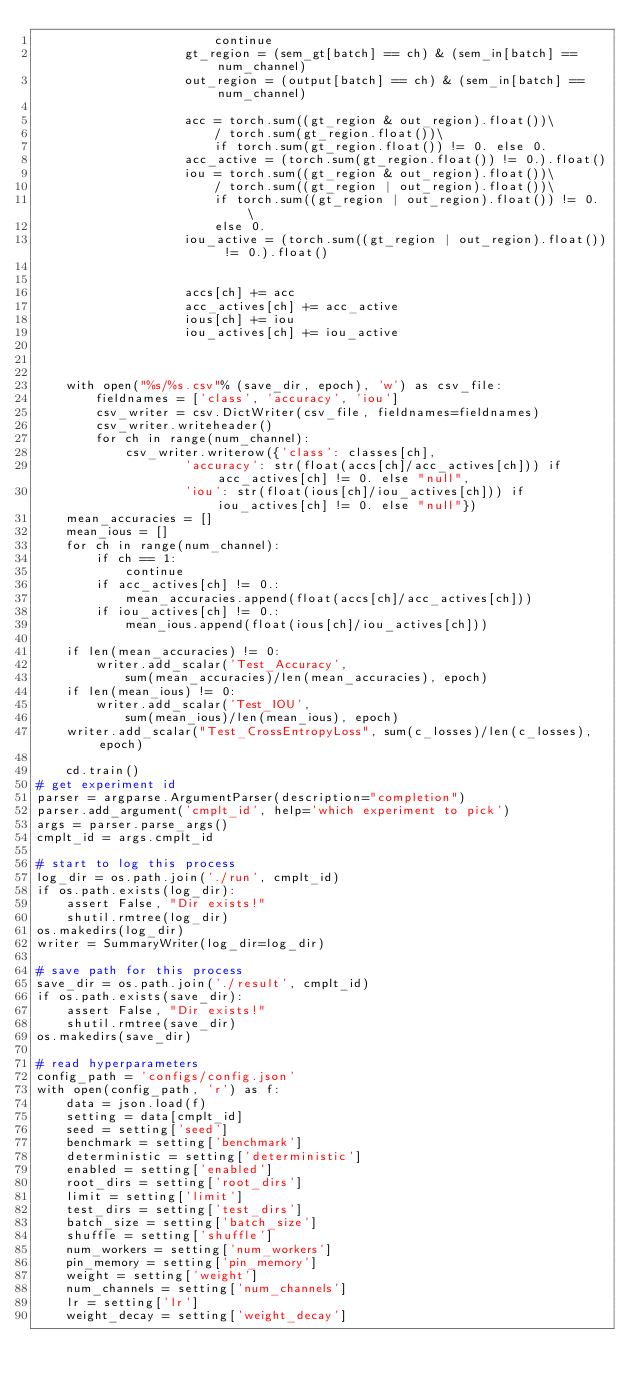Convert code to text. <code><loc_0><loc_0><loc_500><loc_500><_Python_>                        continue
                    gt_region = (sem_gt[batch] == ch) & (sem_in[batch] == num_channel)
                    out_region = (output[batch] == ch) & (sem_in[batch] == num_channel)

                    acc = torch.sum((gt_region & out_region).float())\
                        / torch.sum(gt_region.float())\
                        if torch.sum(gt_region.float()) != 0. else 0.
                    acc_active = (torch.sum(gt_region.float()) != 0.).float()
                    iou = torch.sum((gt_region & out_region).float())\
                        / torch.sum((gt_region | out_region).float())\
                        if torch.sum((gt_region | out_region).float()) != 0. \
                        else 0.
                    iou_active = (torch.sum((gt_region | out_region).float()) != 0.).float()


                    accs[ch] += acc
                    acc_actives[ch] += acc_active
                    ious[ch] += iou
                    iou_actives[ch] += iou_active
            


    with open("%s/%s.csv"% (save_dir, epoch), 'w') as csv_file:
        fieldnames = ['class', 'accuracy', 'iou']
        csv_writer = csv.DictWriter(csv_file, fieldnames=fieldnames)
        csv_writer.writeheader()
        for ch in range(num_channel):
            csv_writer.writerow({'class': classes[ch],
                    'accuracy': str(float(accs[ch]/acc_actives[ch])) if acc_actives[ch] != 0. else "null", 
                    'iou': str(float(ious[ch]/iou_actives[ch])) if iou_actives[ch] != 0. else "null"})
    mean_accuracies = []
    mean_ious = []
    for ch in range(num_channel):
        if ch == 1:
            continue
        if acc_actives[ch] != 0.:
            mean_accuracies.append(float(accs[ch]/acc_actives[ch]))
        if iou_actives[ch] != 0.:
            mean_ious.append(float(ious[ch]/iou_actives[ch]))

    if len(mean_accuracies) != 0:        
        writer.add_scalar('Test_Accuracy',
            sum(mean_accuracies)/len(mean_accuracies), epoch)
    if len(mean_ious) != 0:
        writer.add_scalar('Test_IOU',
            sum(mean_ious)/len(mean_ious), epoch)
    writer.add_scalar("Test_CrossEntropyLoss", sum(c_losses)/len(c_losses), epoch)

    cd.train()
# get experiment id
parser = argparse.ArgumentParser(description="completion")
parser.add_argument('cmplt_id', help='which experiment to pick')
args = parser.parse_args()
cmplt_id = args.cmplt_id

# start to log this process
log_dir = os.path.join('./run', cmplt_id)
if os.path.exists(log_dir):
    assert False, "Dir exists!"
    shutil.rmtree(log_dir)
os.makedirs(log_dir)
writer = SummaryWriter(log_dir=log_dir)

# save path for this process
save_dir = os.path.join('./result', cmplt_id)
if os.path.exists(save_dir):
    assert False, "Dir exists!"
    shutil.rmtree(save_dir)
os.makedirs(save_dir)

# read hyperparameters
config_path = 'configs/config.json'
with open(config_path, 'r') as f:
    data = json.load(f)
    setting = data[cmplt_id]
    seed = setting['seed']
    benchmark = setting['benchmark']
    deterministic = setting['deterministic']
    enabled = setting['enabled']
    root_dirs = setting['root_dirs']
    limit = setting['limit']
    test_dirs = setting['test_dirs']
    batch_size = setting['batch_size']
    shuffle = setting['shuffle']
    num_workers = setting['num_workers']
    pin_memory = setting['pin_memory']
    weight = setting['weight']
    num_channels = setting['num_channels']
    lr = setting['lr']
    weight_decay = setting['weight_decay']</code> 